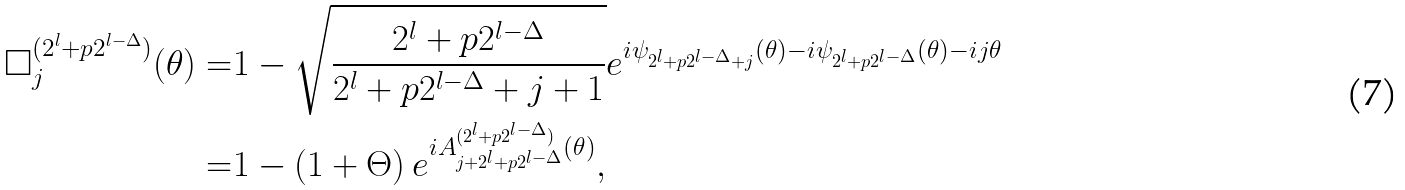<formula> <loc_0><loc_0><loc_500><loc_500>\square _ { j } ^ { ( 2 ^ { l } + p 2 ^ { l - \Delta } ) } ( \theta ) = & 1 - \sqrt { \frac { 2 ^ { l } + p 2 ^ { l - \Delta } } { 2 ^ { l } + p 2 ^ { l - \Delta } + j + 1 } } e ^ { i \psi _ { 2 ^ { l } + p 2 ^ { l - \Delta } + j } ( \theta ) - i \psi _ { 2 ^ { l } + p 2 ^ { l - \Delta } } ( \theta ) - i j \theta } \\ = & 1 - \left ( 1 + \Theta \right ) e ^ { i A _ { j + 2 ^ { l } + p 2 ^ { l - \Delta } } ^ { ( 2 ^ { l } + p 2 ^ { l - \Delta } ) } ( \theta ) } ,</formula> 